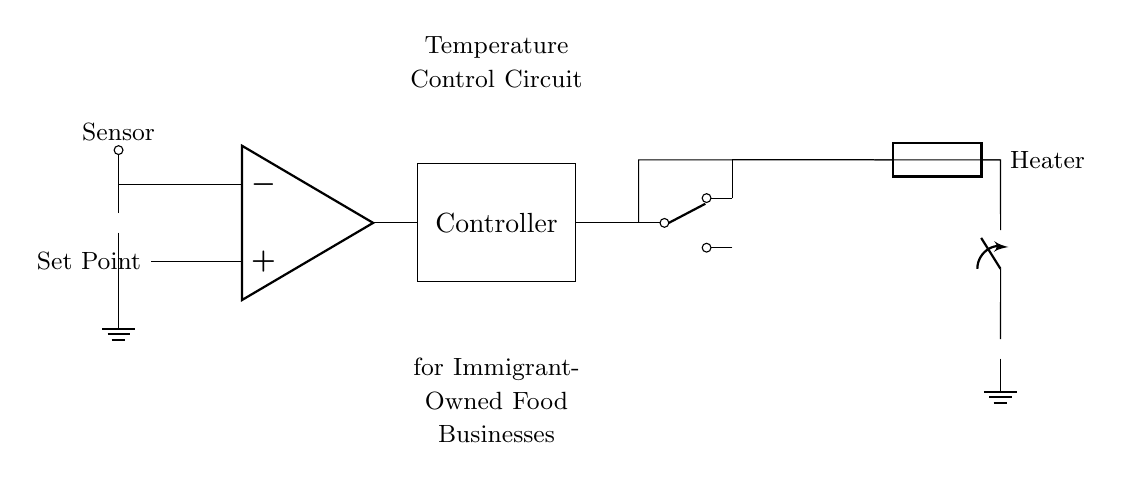What component is used to sense temperature? The component used to sense temperature in this circuit is a thermistor, indicated by the symbol at the left side of the diagram.
Answer: Thermistor What is the function of the operational amplifier in this circuit? The operational amplifier in the circuit acts as a comparator, comparing the temperature sensor's output with the set point to control whether the heater should be activated or not.
Answer: Comparator Where does the power for the circuit come from? The power for the circuit comes from a battery, represented by the symbol at the bottom right of the circuit diagram.
Answer: Battery Which component activates the heater? The relay component activates the heater by connecting it to the power supply when the control signal is high. The output from the controller directs the relay to do this.
Answer: Relay How does the controller determine when to turn on the heater? The controller determines when to turn on the heater by receiving the output from the operational amplifier, which signals whether the current temperature (from the thermistor) is below the set point. If it is, the controller will trigger the relay to turn on the heater.
Answer: By comparing temperatures What is the purpose of the set point in this temperature control circuit? The set point serves as the desired temperature level that the circuit aims to maintain; it is the reference for the comparator in the operational amplifier.
Answer: Desired temperature 